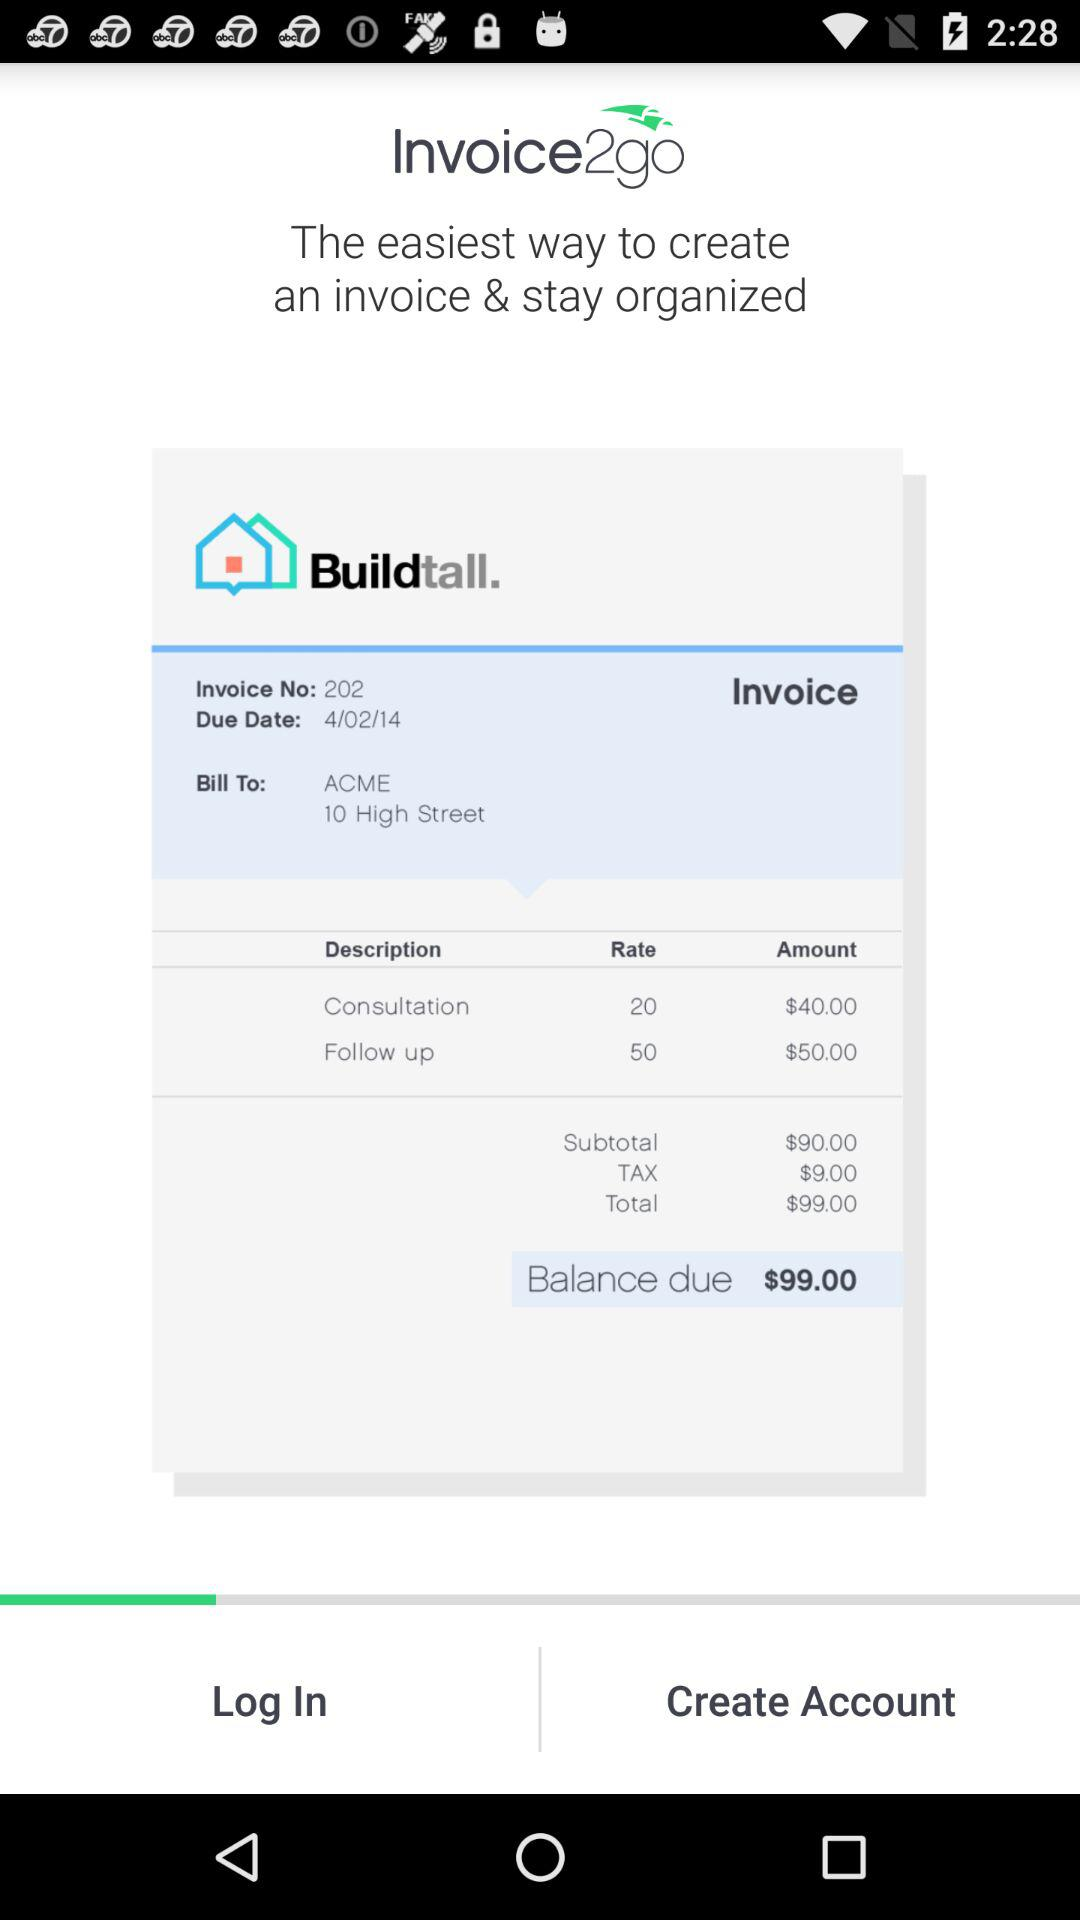What is the subtotal? The subtotal is $90.00. 